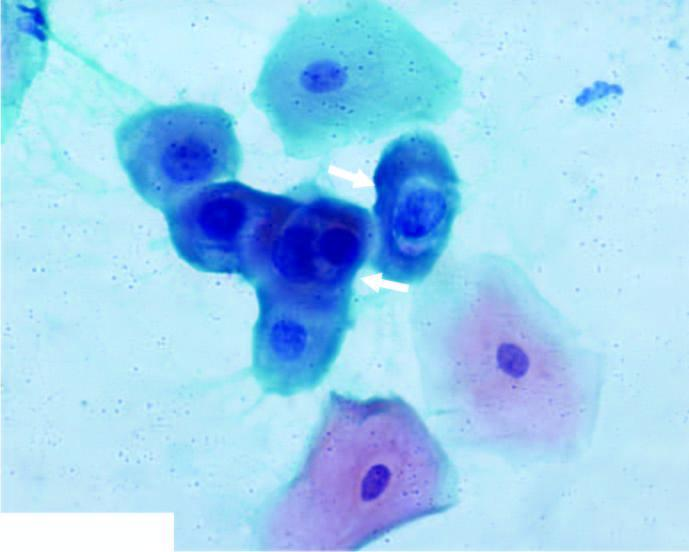what shows koilocytes having abundant vacuolated cytoplasm and nuclear enlargement?
Answer the question using a single word or phrase. The smear 